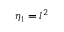<formula> <loc_0><loc_0><loc_500><loc_500>\eta _ { 1 } = l ^ { 2 }</formula> 